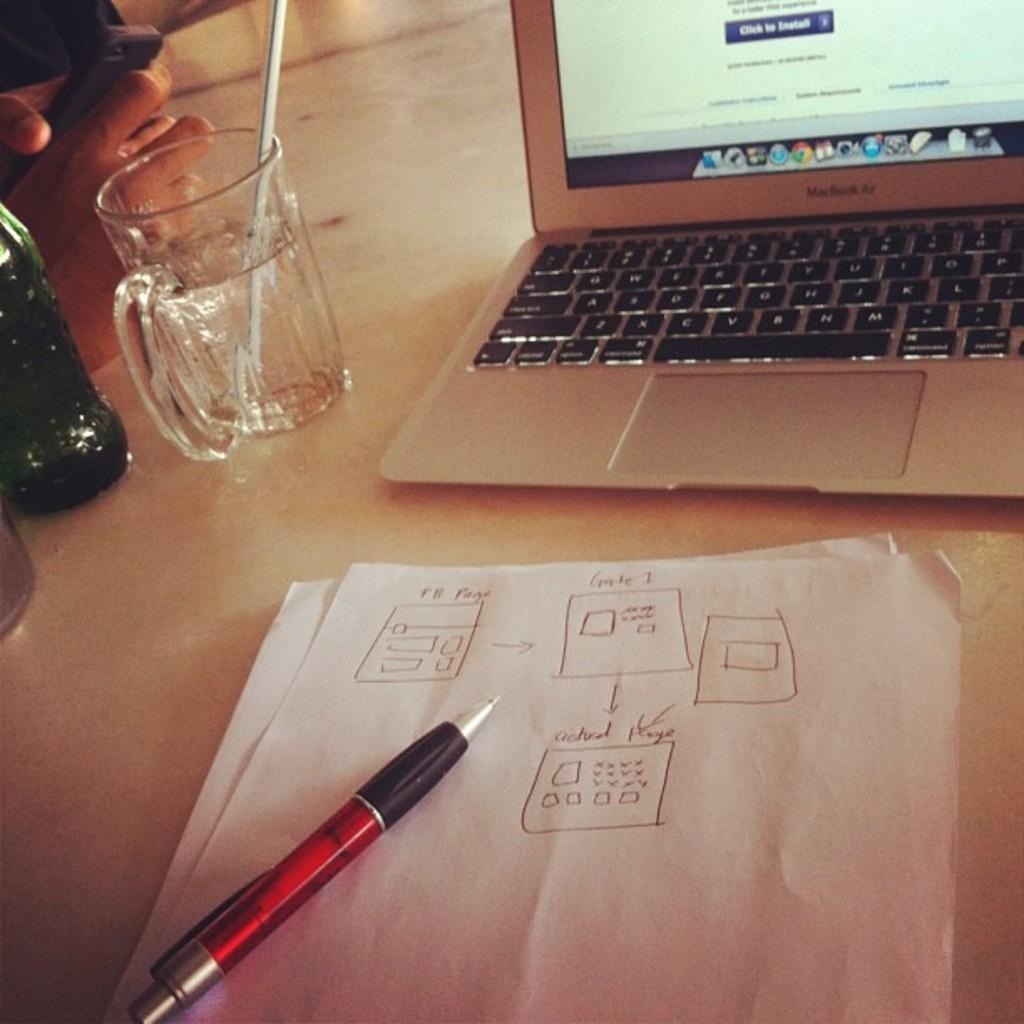What objects can be seen in the image related to writing or drawing? There are papers and a pen in the image. What objects can be seen in the image related to technology? There is a laptop and a mobile in the image. What objects can be seen in the image related to drinking? There is a glass and a bottle in the image. What objects can be seen in the image related to consuming a beverage? There is a straw in the image. What is the color of the platform on which the objects are placed? The objects are on a white platform. How does the person push the wheel in the image? There is no wheel present in the image. What type of wound can be seen on the person's fingers in the image? There is no wound visible on the person's fingers in the image. 